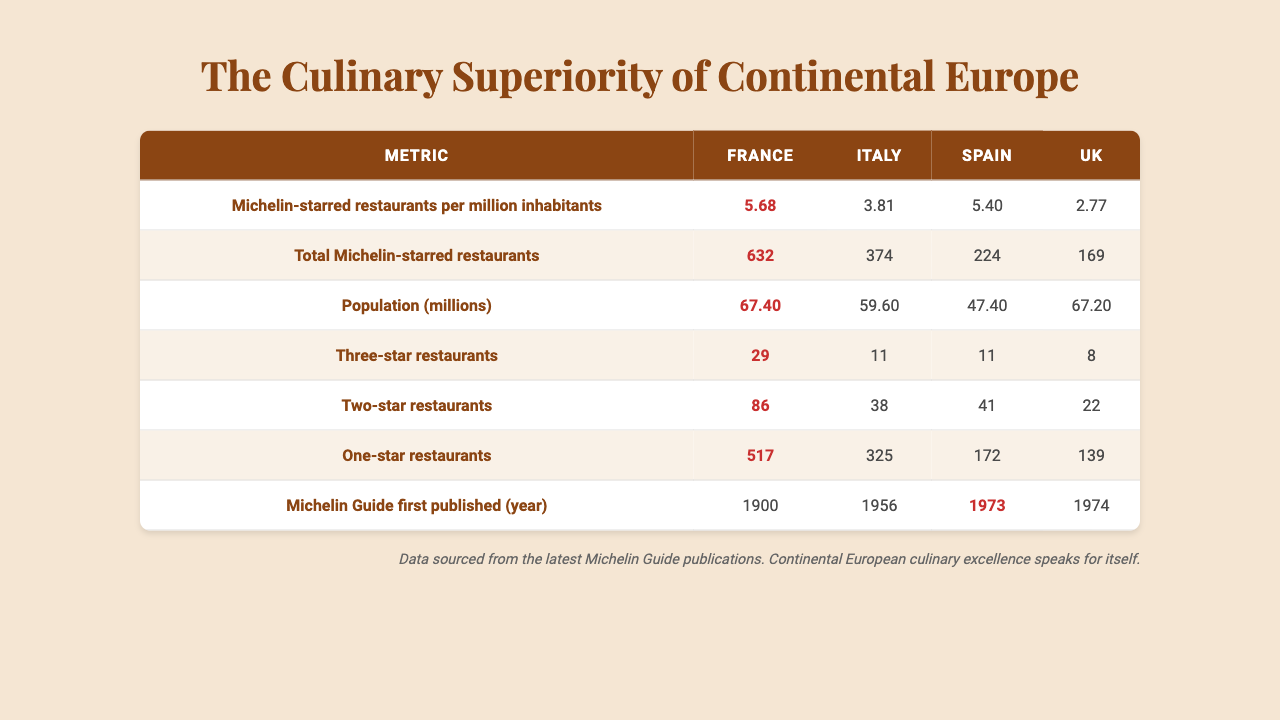What country has the highest number of Michelin-starred restaurants per million inhabitants? Examining the first row of the table, France has a value of 5.68, Italy has 3.81, Spain has 5.40, and the UK has 2.77. France's value is the highest among the four countries.
Answer: France What is the total number of Michelin-starred restaurants in Italy? Looking at the second row for Italy, the value is 374. This is the total number of Michelin-starred restaurants listed for Italy in the table.
Answer: 374 How many three-star Michelin restaurants does the UK have? Referring to the fourth row in the table, the UK has 8 three-star Michelin restaurants.
Answer: 8 Which country has the lowest number of two-star Michelin restaurants, and what is that number? In the fifth row, we see that the UK has 22 two-star restaurants, which is fewer than Italy (38) and Spain (41). Therefore, the UK has the lowest number of two-star restaurants.
Answer: UK; 22 What is the average number of Michelin-starred restaurants per million inhabitants for France, Italy, and Spain? The number for France is 5.68, for Italy is 3.81, and for Spain is 5.40. To find the average: (5.68 + 3.81 + 5.40) / 3 = 4.63.
Answer: 4.63 Does Spain have a higher total number of Michelin-starred restaurants than the UK? Spain has a total of 224 Michelin-starred restaurants, while the UK has 169. Thus, Spain does have a higher total.
Answer: Yes What is the difference in population (in millions) between France and Italy? France's population is 67.4 million and Italy's is 59.6 million. The difference is 67.4 - 59.6 = 7.8 million.
Answer: 7.8 million Which country has more one-star Michelin restaurants, Spain or the UK? Spain has 172 one-star Michelin restaurants, while the UK has 139. Since 172 is greater than 139, Spain has more.
Answer: Spain What year was the Michelin Guide first published in France? Looking at the last row of the table for France, the Michelin Guide was first published in 1900.
Answer: 1900 If we add the total Michelin-starred restaurants from France and Italy, what is the result? The total for France is 632 and for Italy is 374. Adding these together gives 632 + 374 = 1006.
Answer: 1006 